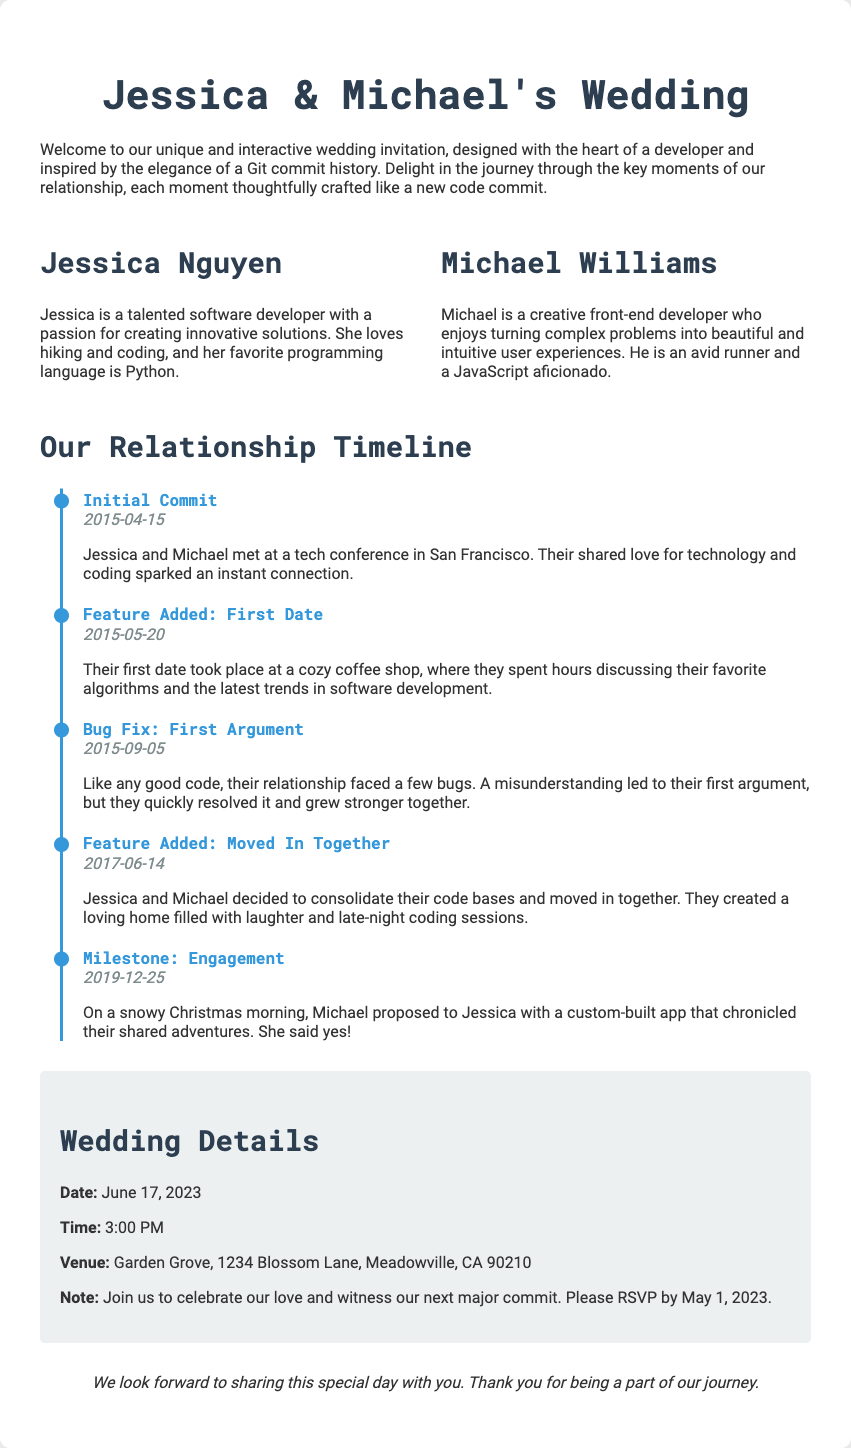What is the couple's wedding date? The wedding date is specified in the details section of the document.
Answer: June 17, 2023 Who proposed to Jessica? The document states who made the proposal in the engagement milestone event.
Answer: Michael What did Michael use to propose? The engagement event describes the method of the proposal.
Answer: Custom-built app When did they move in together? The move-in date is shared in the timeline of their relationship.
Answer: 2017-06-14 What is Jessica's favorite programming language? Jessica's favorite programming language is mentioned in her profile section.
Answer: Python What city is the wedding venue located in? The venue details mention the city where the wedding will take place.
Answer: Meadowville What significant event occurred on December 25, 2019? The engagement timeline event provides information about this date's significance.
Answer: Engagement What was the first event in their timeline? The initial event listed in the timeline represents the start of their journey.
Answer: Initial Commit 